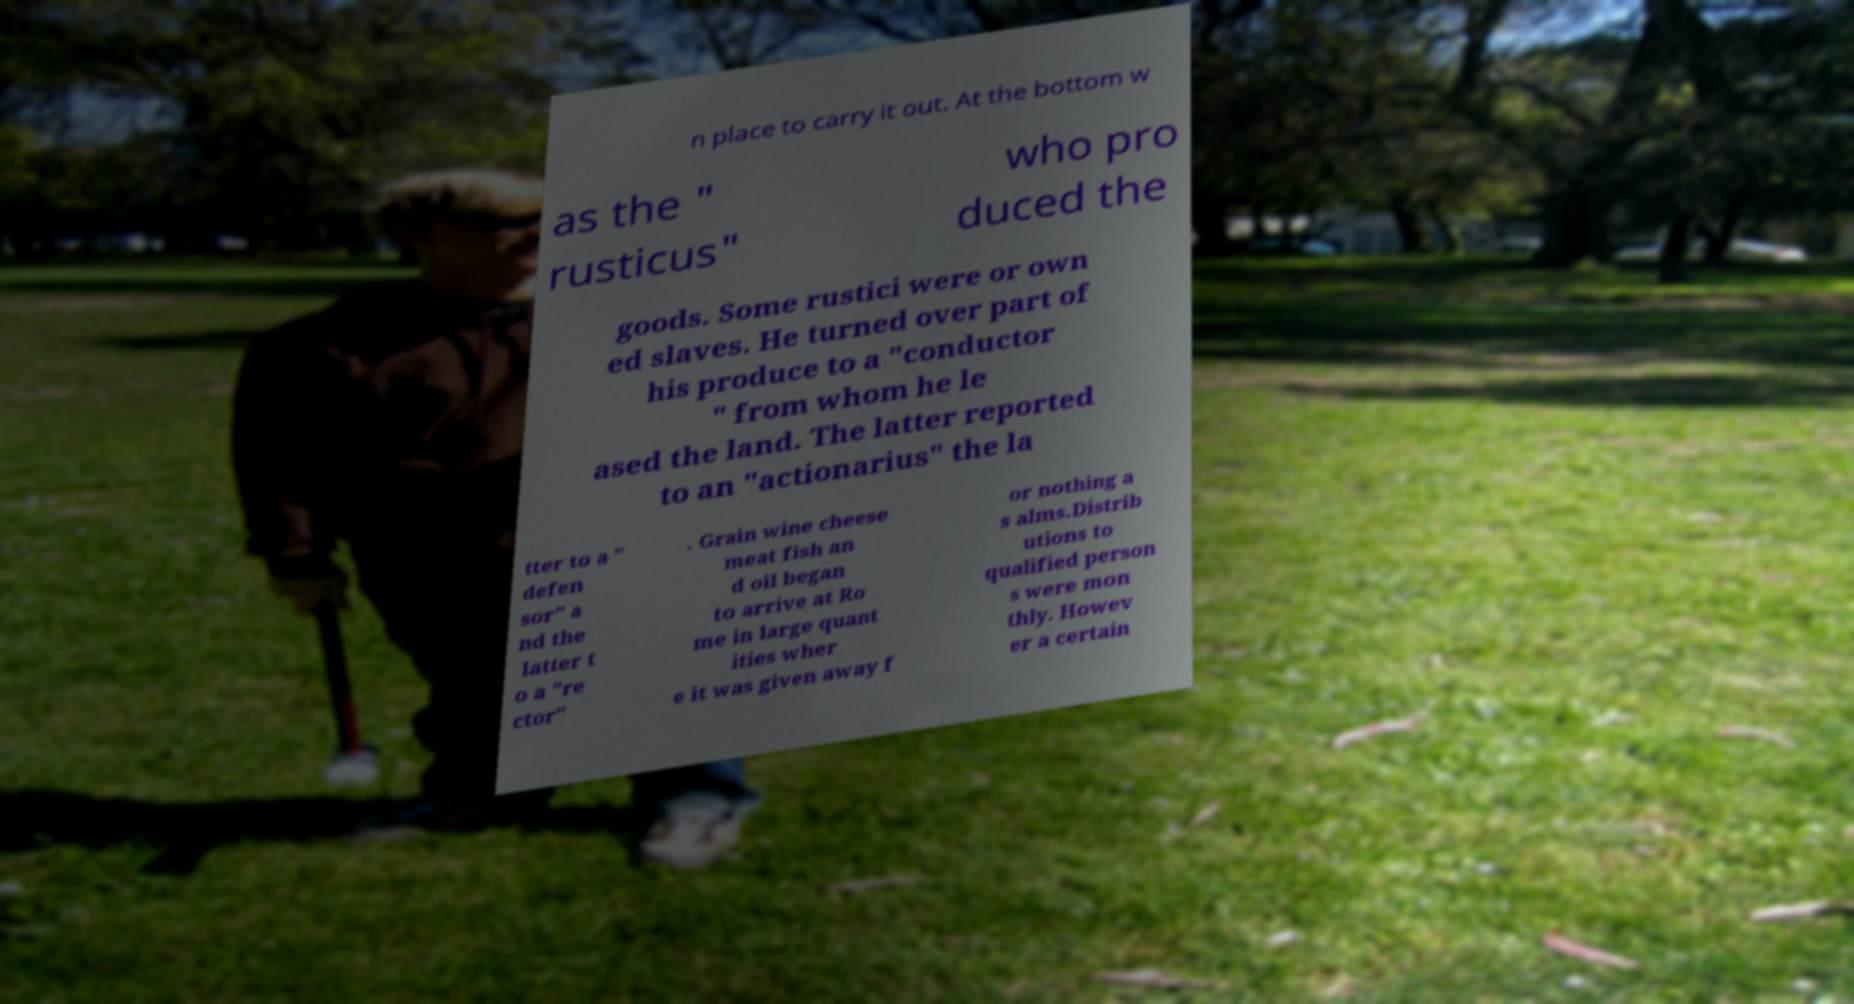Can you accurately transcribe the text from the provided image for me? n place to carry it out. At the bottom w as the " rusticus" who pro duced the goods. Some rustici were or own ed slaves. He turned over part of his produce to a "conductor " from whom he le ased the land. The latter reported to an "actionarius" the la tter to a " defen sor" a nd the latter t o a "re ctor" . Grain wine cheese meat fish an d oil began to arrive at Ro me in large quant ities wher e it was given away f or nothing a s alms.Distrib utions to qualified person s were mon thly. Howev er a certain 